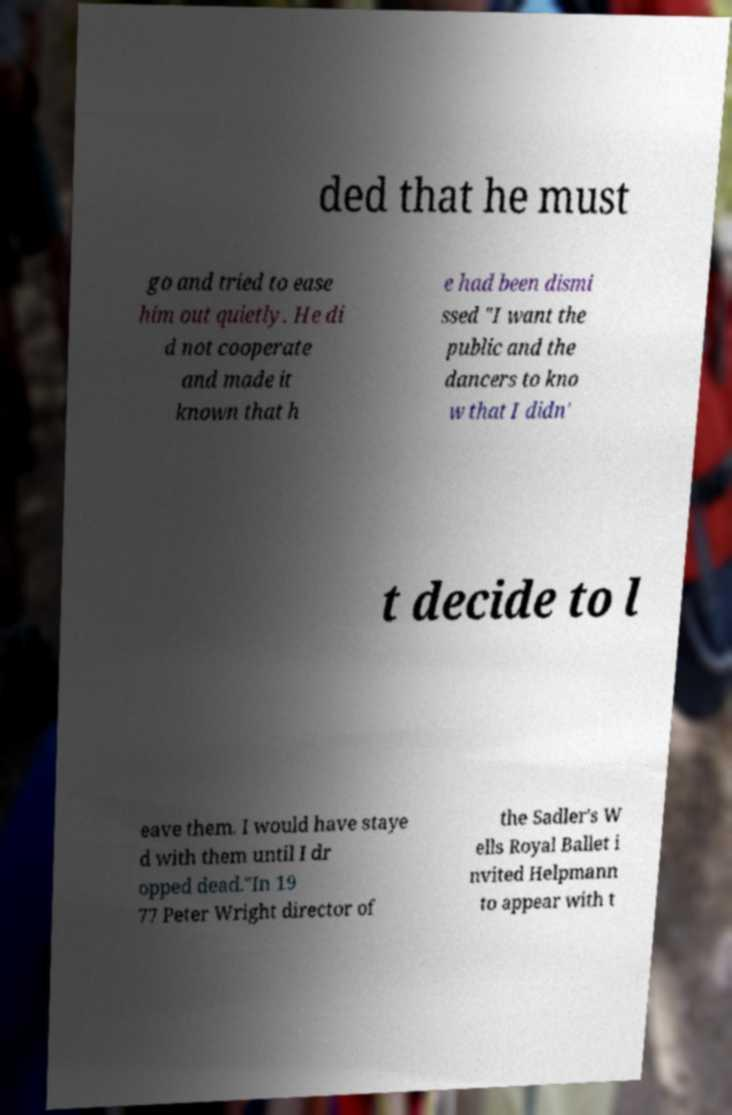Can you accurately transcribe the text from the provided image for me? ded that he must go and tried to ease him out quietly. He di d not cooperate and made it known that h e had been dismi ssed "I want the public and the dancers to kno w that I didn' t decide to l eave them. I would have staye d with them until I dr opped dead."In 19 77 Peter Wright director of the Sadler's W ells Royal Ballet i nvited Helpmann to appear with t 